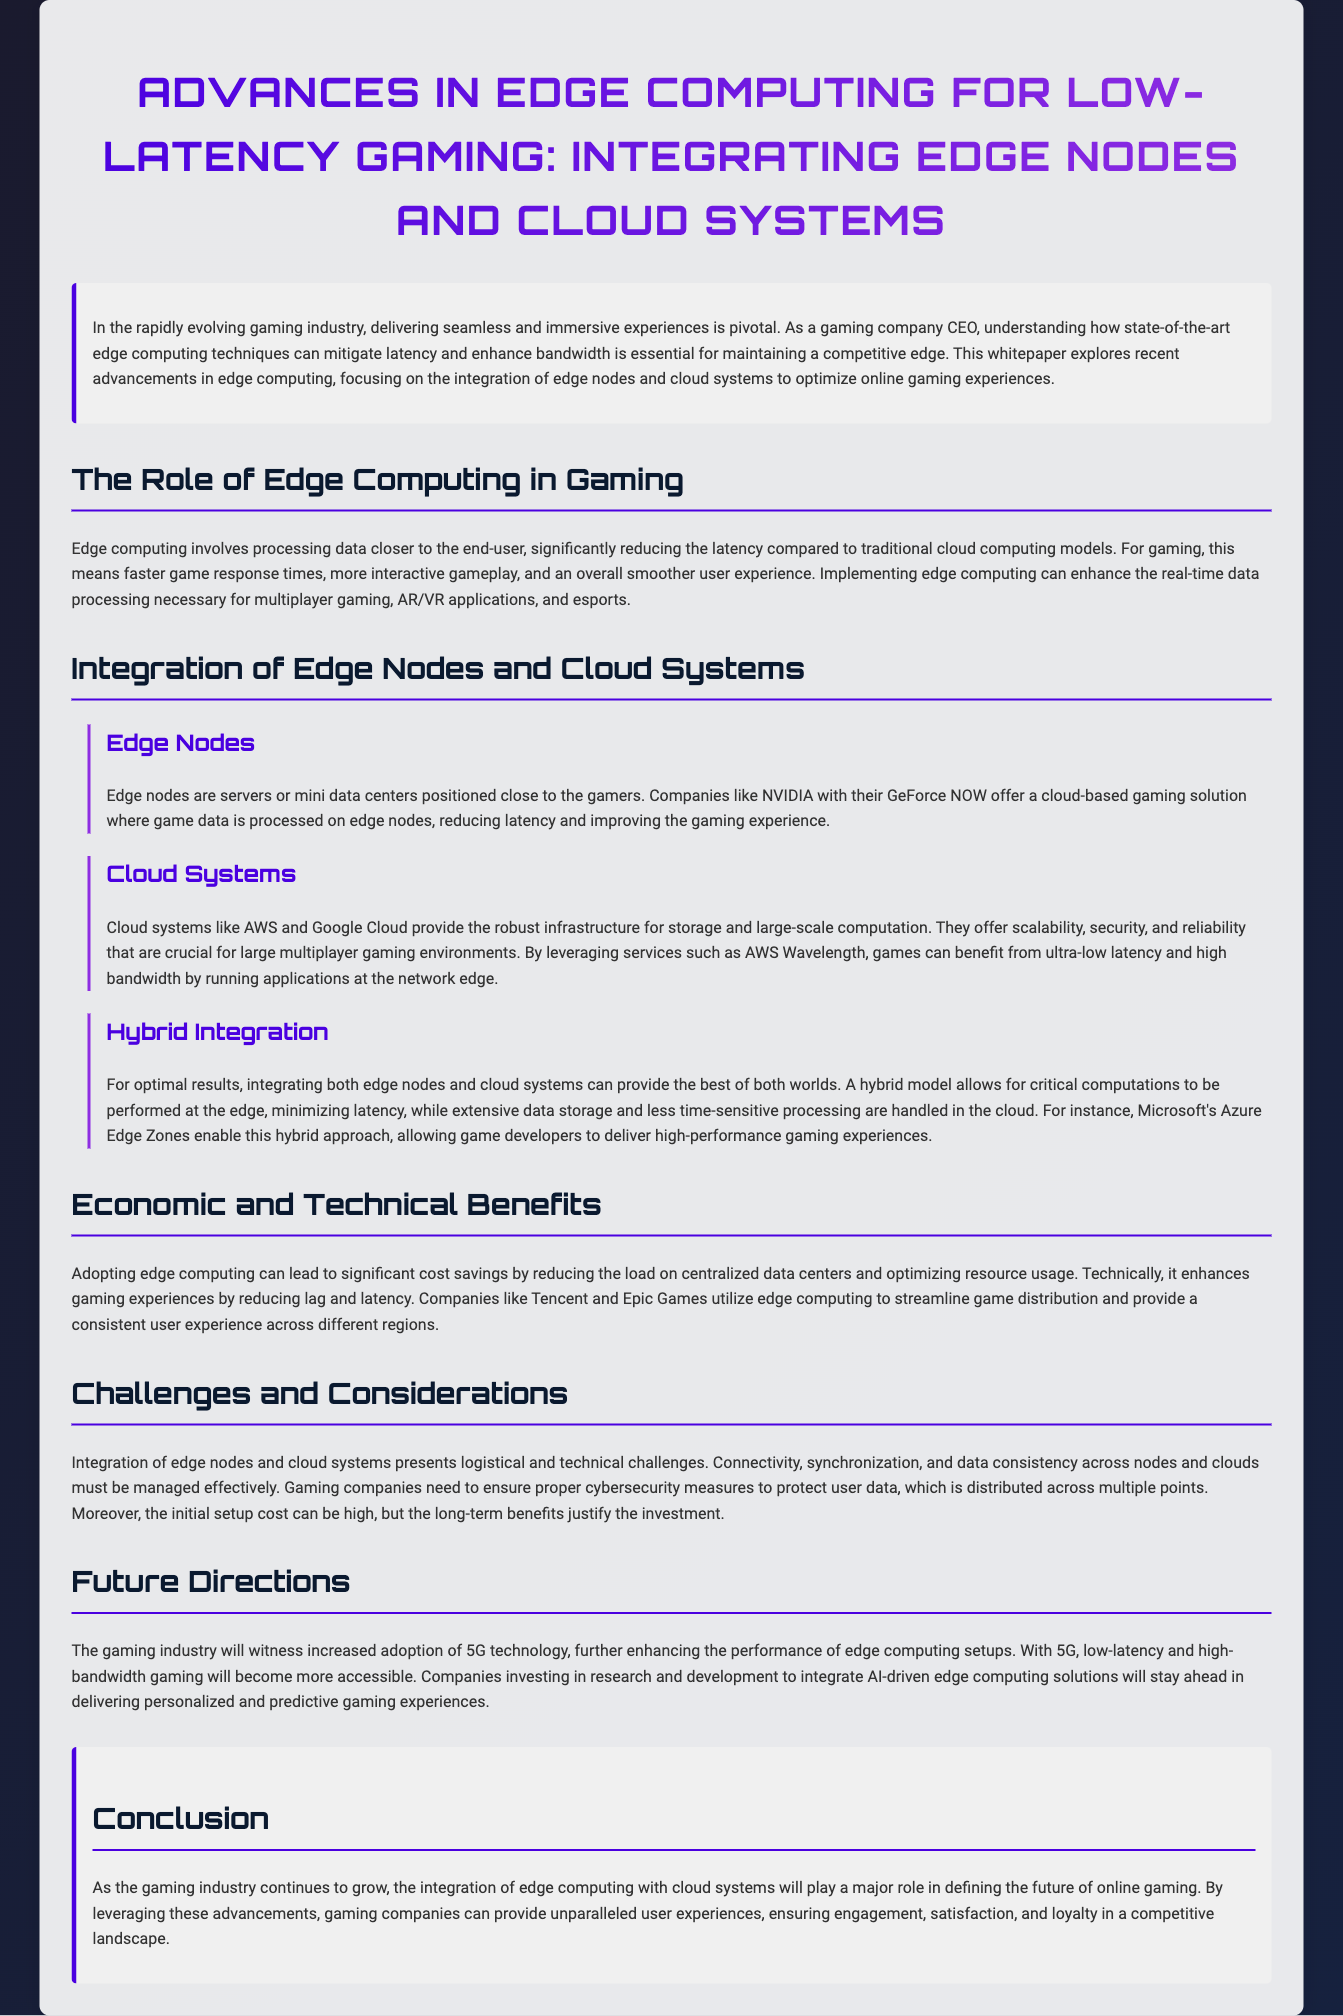What is the primary focus of the whitepaper? The primary focus of the whitepaper is on how edge computing techniques can mitigate latency and enhance bandwidth in the gaming industry.
Answer: Edge computing techniques What are edge nodes? Edge nodes are servers or mini data centers positioned close to the gamers to process game data, reducing latency.
Answer: Servers or mini data centers Which company offers a cloud-based gaming solution utilizing edge nodes? NVIDIA offers a cloud-based gaming solution where game data is processed on edge nodes.
Answer: NVIDIA What is a benefit of integrating both edge nodes and cloud systems? Integrating both allows critical computations at the edge, minimizing latency, and handles extensive data in the cloud.
Answer: Minimizing latency What technology is expected to enhance edge computing setups in gaming? The gaming industry will witness increased adoption of 5G technology enhancing edge computing setups.
Answer: 5G technology What are the economic benefits of adopting edge computing? Adopting edge computing can lead to significant cost savings by reducing the load on centralized data centers.
Answer: Cost savings What is one challenge of integrating edge nodes and cloud systems? Connectivity, synchronization, and data consistency across nodes and clouds must be effectively managed.
Answer: Connectivity Which game companies utilize edge computing for improved user experience? Tencent and Epic Games utilize edge computing to streamline game distribution.
Answer: Tencent and Epic Games What approach do Microsoft's Azure Edge Zones represent? Microsoft's Azure Edge Zones enable a hybrid approach to gaming infrastructure.
Answer: Hybrid approach 